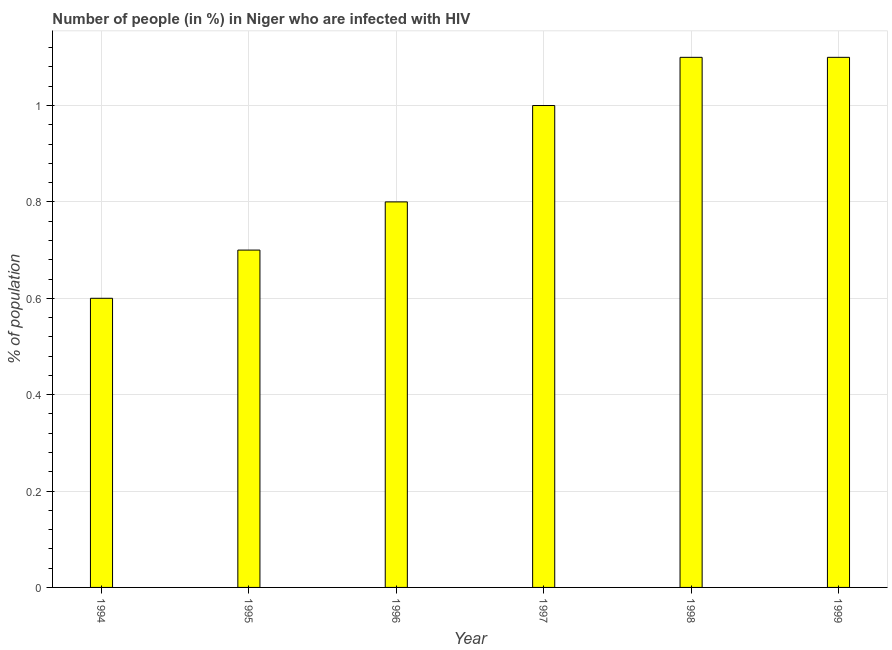Does the graph contain any zero values?
Offer a very short reply. No. What is the title of the graph?
Your answer should be compact. Number of people (in %) in Niger who are infected with HIV. What is the label or title of the Y-axis?
Provide a succinct answer. % of population. What is the number of people infected with hiv in 1999?
Your response must be concise. 1.1. In which year was the number of people infected with hiv maximum?
Provide a succinct answer. 1998. What is the sum of the number of people infected with hiv?
Give a very brief answer. 5.3. What is the average number of people infected with hiv per year?
Give a very brief answer. 0.88. In how many years, is the number of people infected with hiv greater than 0.28 %?
Provide a short and direct response. 6. What is the ratio of the number of people infected with hiv in 1994 to that in 1995?
Make the answer very short. 0.86. Is the number of people infected with hiv in 1997 less than that in 1999?
Offer a very short reply. Yes. Is the difference between the number of people infected with hiv in 1994 and 1996 greater than the difference between any two years?
Provide a short and direct response. No. Is the sum of the number of people infected with hiv in 1994 and 1998 greater than the maximum number of people infected with hiv across all years?
Keep it short and to the point. Yes. What is the difference between the highest and the lowest number of people infected with hiv?
Your answer should be very brief. 0.5. Are the values on the major ticks of Y-axis written in scientific E-notation?
Keep it short and to the point. No. What is the % of population in 1994?
Offer a terse response. 0.6. What is the % of population of 1995?
Your answer should be compact. 0.7. What is the % of population of 1996?
Offer a terse response. 0.8. What is the % of population of 1998?
Provide a short and direct response. 1.1. What is the difference between the % of population in 1994 and 1995?
Offer a very short reply. -0.1. What is the difference between the % of population in 1994 and 1996?
Offer a terse response. -0.2. What is the difference between the % of population in 1994 and 1997?
Ensure brevity in your answer.  -0.4. What is the difference between the % of population in 1994 and 1998?
Your answer should be compact. -0.5. What is the difference between the % of population in 1995 and 1997?
Give a very brief answer. -0.3. What is the difference between the % of population in 1995 and 1999?
Your response must be concise. -0.4. What is the difference between the % of population in 1996 and 1997?
Offer a very short reply. -0.2. What is the difference between the % of population in 1996 and 1999?
Your response must be concise. -0.3. What is the difference between the % of population in 1997 and 1998?
Give a very brief answer. -0.1. What is the difference between the % of population in 1997 and 1999?
Offer a terse response. -0.1. What is the difference between the % of population in 1998 and 1999?
Keep it short and to the point. 0. What is the ratio of the % of population in 1994 to that in 1995?
Keep it short and to the point. 0.86. What is the ratio of the % of population in 1994 to that in 1998?
Provide a succinct answer. 0.55. What is the ratio of the % of population in 1994 to that in 1999?
Your response must be concise. 0.55. What is the ratio of the % of population in 1995 to that in 1996?
Offer a very short reply. 0.88. What is the ratio of the % of population in 1995 to that in 1997?
Your response must be concise. 0.7. What is the ratio of the % of population in 1995 to that in 1998?
Offer a terse response. 0.64. What is the ratio of the % of population in 1995 to that in 1999?
Provide a succinct answer. 0.64. What is the ratio of the % of population in 1996 to that in 1997?
Offer a terse response. 0.8. What is the ratio of the % of population in 1996 to that in 1998?
Ensure brevity in your answer.  0.73. What is the ratio of the % of population in 1996 to that in 1999?
Provide a short and direct response. 0.73. What is the ratio of the % of population in 1997 to that in 1998?
Give a very brief answer. 0.91. What is the ratio of the % of population in 1997 to that in 1999?
Offer a very short reply. 0.91. What is the ratio of the % of population in 1998 to that in 1999?
Offer a very short reply. 1. 